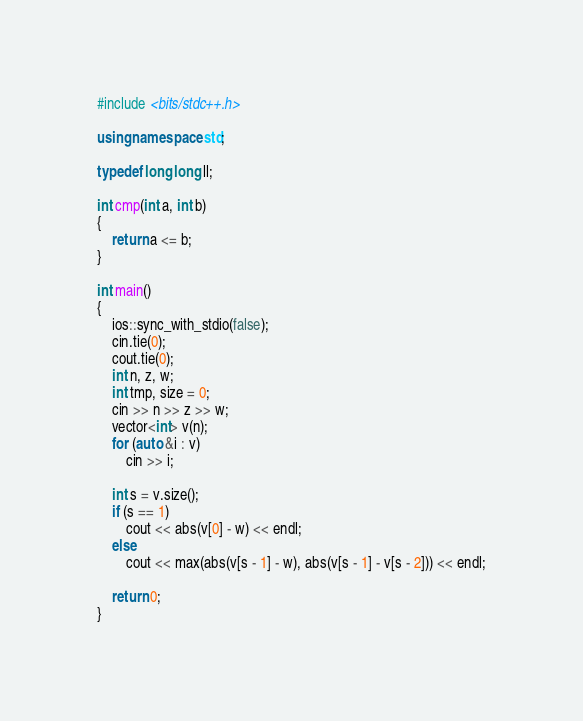<code> <loc_0><loc_0><loc_500><loc_500><_C++_>#include <bits/stdc++.h>

using namespace std;

typedef long long ll;

int cmp(int a, int b)
{
    return a <= b;
}

int main()
{
    ios::sync_with_stdio(false);
    cin.tie(0);
    cout.tie(0);
    int n, z, w;
    int tmp, size = 0;
    cin >> n >> z >> w;
    vector<int> v(n);
    for (auto &i : v)
        cin >> i;

    int s = v.size();
    if (s == 1)
        cout << abs(v[0] - w) << endl;
    else
        cout << max(abs(v[s - 1] - w), abs(v[s - 1] - v[s - 2])) << endl;

    return 0;
}</code> 